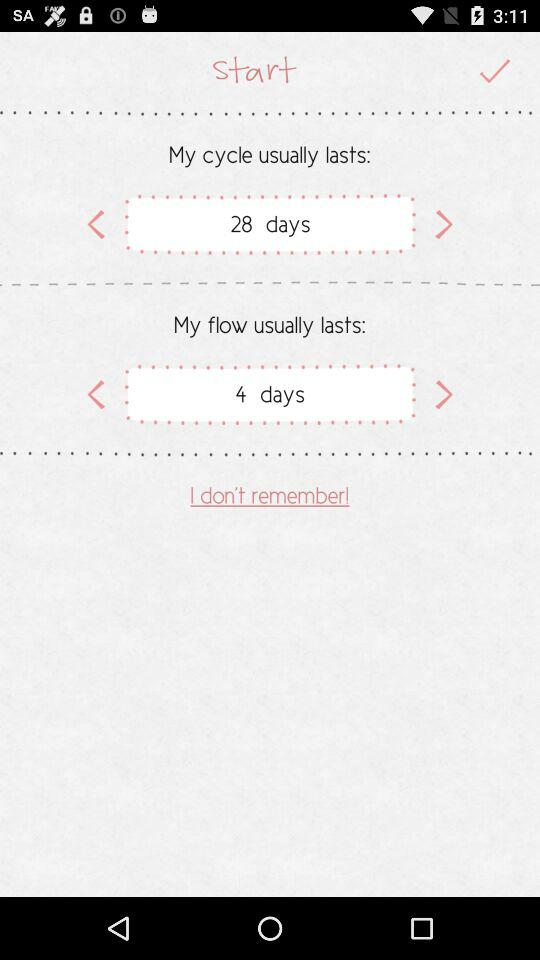How long does my cycle usually last? My cycle usually lasts 28 days. 